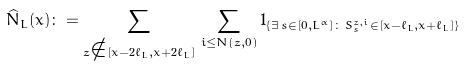Convert formula to latex. <formula><loc_0><loc_0><loc_500><loc_500>\widehat { N } _ { L } ( x ) \colon = \sum _ { z \notin [ x - 2 \ell _ { L } , x + 2 \ell _ { L } ] } \, \sum _ { i \leq N ( z , 0 ) } 1 _ { \{ \exists \, s \in [ 0 , L ^ { \alpha } ] \colon \, S ^ { z , i } _ { s } \in [ x - \ell _ { L } , x + \ell _ { L } ] \} }</formula> 